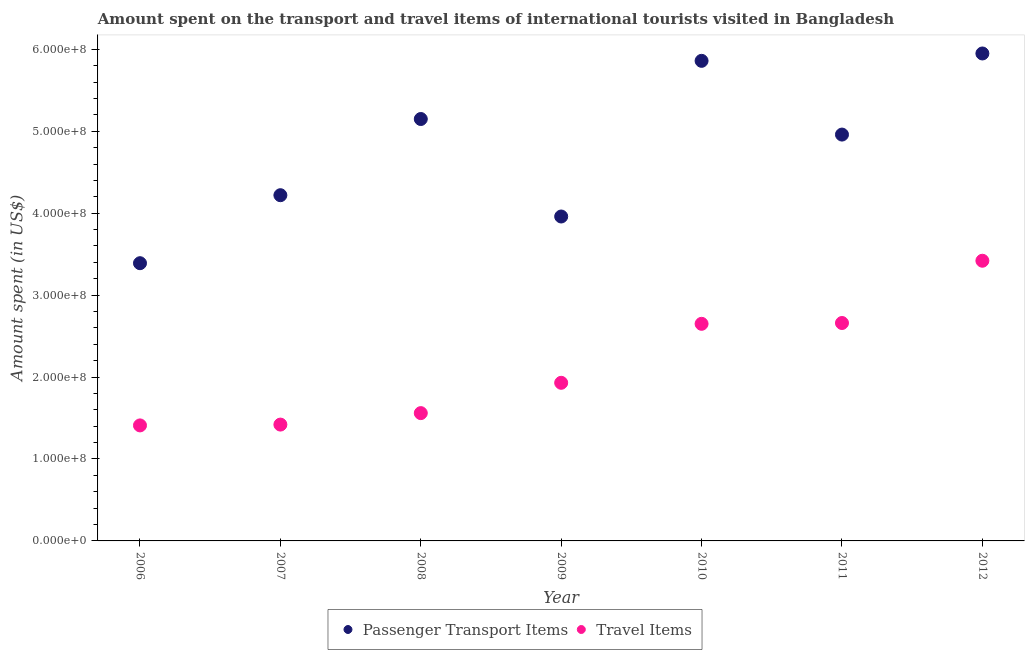What is the amount spent in travel items in 2012?
Offer a very short reply. 3.42e+08. Across all years, what is the maximum amount spent on passenger transport items?
Give a very brief answer. 5.95e+08. Across all years, what is the minimum amount spent in travel items?
Offer a terse response. 1.41e+08. In which year was the amount spent in travel items maximum?
Give a very brief answer. 2012. What is the total amount spent on passenger transport items in the graph?
Your response must be concise. 3.35e+09. What is the difference between the amount spent on passenger transport items in 2007 and that in 2012?
Give a very brief answer. -1.73e+08. What is the difference between the amount spent in travel items in 2010 and the amount spent on passenger transport items in 2006?
Make the answer very short. -7.40e+07. What is the average amount spent on passenger transport items per year?
Provide a succinct answer. 4.78e+08. In the year 2012, what is the difference between the amount spent in travel items and amount spent on passenger transport items?
Give a very brief answer. -2.53e+08. In how many years, is the amount spent in travel items greater than 80000000 US$?
Offer a very short reply. 7. What is the ratio of the amount spent on passenger transport items in 2010 to that in 2012?
Your response must be concise. 0.98. Is the difference between the amount spent on passenger transport items in 2007 and 2012 greater than the difference between the amount spent in travel items in 2007 and 2012?
Keep it short and to the point. Yes. What is the difference between the highest and the second highest amount spent on passenger transport items?
Offer a terse response. 9.00e+06. What is the difference between the highest and the lowest amount spent in travel items?
Keep it short and to the point. 2.01e+08. Is the sum of the amount spent on passenger transport items in 2009 and 2011 greater than the maximum amount spent in travel items across all years?
Make the answer very short. Yes. Does the amount spent in travel items monotonically increase over the years?
Ensure brevity in your answer.  Yes. Is the amount spent on passenger transport items strictly less than the amount spent in travel items over the years?
Your response must be concise. No. How many dotlines are there?
Ensure brevity in your answer.  2. What is the difference between two consecutive major ticks on the Y-axis?
Provide a short and direct response. 1.00e+08. Does the graph contain any zero values?
Give a very brief answer. No. Does the graph contain grids?
Offer a terse response. No. Where does the legend appear in the graph?
Provide a short and direct response. Bottom center. How are the legend labels stacked?
Give a very brief answer. Horizontal. What is the title of the graph?
Your answer should be very brief. Amount spent on the transport and travel items of international tourists visited in Bangladesh. Does "Short-term debt" appear as one of the legend labels in the graph?
Make the answer very short. No. What is the label or title of the Y-axis?
Ensure brevity in your answer.  Amount spent (in US$). What is the Amount spent (in US$) in Passenger Transport Items in 2006?
Ensure brevity in your answer.  3.39e+08. What is the Amount spent (in US$) of Travel Items in 2006?
Offer a terse response. 1.41e+08. What is the Amount spent (in US$) in Passenger Transport Items in 2007?
Make the answer very short. 4.22e+08. What is the Amount spent (in US$) in Travel Items in 2007?
Offer a terse response. 1.42e+08. What is the Amount spent (in US$) in Passenger Transport Items in 2008?
Provide a succinct answer. 5.15e+08. What is the Amount spent (in US$) of Travel Items in 2008?
Your response must be concise. 1.56e+08. What is the Amount spent (in US$) in Passenger Transport Items in 2009?
Make the answer very short. 3.96e+08. What is the Amount spent (in US$) in Travel Items in 2009?
Ensure brevity in your answer.  1.93e+08. What is the Amount spent (in US$) of Passenger Transport Items in 2010?
Keep it short and to the point. 5.86e+08. What is the Amount spent (in US$) in Travel Items in 2010?
Provide a short and direct response. 2.65e+08. What is the Amount spent (in US$) in Passenger Transport Items in 2011?
Your answer should be compact. 4.96e+08. What is the Amount spent (in US$) in Travel Items in 2011?
Keep it short and to the point. 2.66e+08. What is the Amount spent (in US$) in Passenger Transport Items in 2012?
Keep it short and to the point. 5.95e+08. What is the Amount spent (in US$) of Travel Items in 2012?
Provide a succinct answer. 3.42e+08. Across all years, what is the maximum Amount spent (in US$) in Passenger Transport Items?
Provide a succinct answer. 5.95e+08. Across all years, what is the maximum Amount spent (in US$) in Travel Items?
Offer a terse response. 3.42e+08. Across all years, what is the minimum Amount spent (in US$) of Passenger Transport Items?
Provide a short and direct response. 3.39e+08. Across all years, what is the minimum Amount spent (in US$) in Travel Items?
Offer a very short reply. 1.41e+08. What is the total Amount spent (in US$) of Passenger Transport Items in the graph?
Offer a terse response. 3.35e+09. What is the total Amount spent (in US$) in Travel Items in the graph?
Make the answer very short. 1.50e+09. What is the difference between the Amount spent (in US$) in Passenger Transport Items in 2006 and that in 2007?
Provide a short and direct response. -8.30e+07. What is the difference between the Amount spent (in US$) of Passenger Transport Items in 2006 and that in 2008?
Your response must be concise. -1.76e+08. What is the difference between the Amount spent (in US$) of Travel Items in 2006 and that in 2008?
Your response must be concise. -1.50e+07. What is the difference between the Amount spent (in US$) in Passenger Transport Items in 2006 and that in 2009?
Provide a succinct answer. -5.70e+07. What is the difference between the Amount spent (in US$) in Travel Items in 2006 and that in 2009?
Provide a short and direct response. -5.20e+07. What is the difference between the Amount spent (in US$) in Passenger Transport Items in 2006 and that in 2010?
Your answer should be very brief. -2.47e+08. What is the difference between the Amount spent (in US$) of Travel Items in 2006 and that in 2010?
Make the answer very short. -1.24e+08. What is the difference between the Amount spent (in US$) of Passenger Transport Items in 2006 and that in 2011?
Ensure brevity in your answer.  -1.57e+08. What is the difference between the Amount spent (in US$) in Travel Items in 2006 and that in 2011?
Your answer should be compact. -1.25e+08. What is the difference between the Amount spent (in US$) of Passenger Transport Items in 2006 and that in 2012?
Your answer should be compact. -2.56e+08. What is the difference between the Amount spent (in US$) in Travel Items in 2006 and that in 2012?
Your answer should be very brief. -2.01e+08. What is the difference between the Amount spent (in US$) in Passenger Transport Items in 2007 and that in 2008?
Your answer should be compact. -9.30e+07. What is the difference between the Amount spent (in US$) of Travel Items in 2007 and that in 2008?
Make the answer very short. -1.40e+07. What is the difference between the Amount spent (in US$) in Passenger Transport Items in 2007 and that in 2009?
Your answer should be very brief. 2.60e+07. What is the difference between the Amount spent (in US$) of Travel Items in 2007 and that in 2009?
Ensure brevity in your answer.  -5.10e+07. What is the difference between the Amount spent (in US$) of Passenger Transport Items in 2007 and that in 2010?
Your response must be concise. -1.64e+08. What is the difference between the Amount spent (in US$) of Travel Items in 2007 and that in 2010?
Provide a succinct answer. -1.23e+08. What is the difference between the Amount spent (in US$) in Passenger Transport Items in 2007 and that in 2011?
Give a very brief answer. -7.40e+07. What is the difference between the Amount spent (in US$) in Travel Items in 2007 and that in 2011?
Provide a succinct answer. -1.24e+08. What is the difference between the Amount spent (in US$) of Passenger Transport Items in 2007 and that in 2012?
Make the answer very short. -1.73e+08. What is the difference between the Amount spent (in US$) in Travel Items in 2007 and that in 2012?
Provide a short and direct response. -2.00e+08. What is the difference between the Amount spent (in US$) in Passenger Transport Items in 2008 and that in 2009?
Make the answer very short. 1.19e+08. What is the difference between the Amount spent (in US$) in Travel Items in 2008 and that in 2009?
Make the answer very short. -3.70e+07. What is the difference between the Amount spent (in US$) in Passenger Transport Items in 2008 and that in 2010?
Provide a short and direct response. -7.10e+07. What is the difference between the Amount spent (in US$) in Travel Items in 2008 and that in 2010?
Give a very brief answer. -1.09e+08. What is the difference between the Amount spent (in US$) of Passenger Transport Items in 2008 and that in 2011?
Provide a succinct answer. 1.90e+07. What is the difference between the Amount spent (in US$) in Travel Items in 2008 and that in 2011?
Offer a terse response. -1.10e+08. What is the difference between the Amount spent (in US$) of Passenger Transport Items in 2008 and that in 2012?
Your answer should be very brief. -8.00e+07. What is the difference between the Amount spent (in US$) of Travel Items in 2008 and that in 2012?
Provide a succinct answer. -1.86e+08. What is the difference between the Amount spent (in US$) of Passenger Transport Items in 2009 and that in 2010?
Your answer should be very brief. -1.90e+08. What is the difference between the Amount spent (in US$) of Travel Items in 2009 and that in 2010?
Your response must be concise. -7.20e+07. What is the difference between the Amount spent (in US$) of Passenger Transport Items in 2009 and that in 2011?
Provide a short and direct response. -1.00e+08. What is the difference between the Amount spent (in US$) in Travel Items in 2009 and that in 2011?
Your response must be concise. -7.30e+07. What is the difference between the Amount spent (in US$) in Passenger Transport Items in 2009 and that in 2012?
Offer a terse response. -1.99e+08. What is the difference between the Amount spent (in US$) of Travel Items in 2009 and that in 2012?
Your response must be concise. -1.49e+08. What is the difference between the Amount spent (in US$) of Passenger Transport Items in 2010 and that in 2011?
Offer a very short reply. 9.00e+07. What is the difference between the Amount spent (in US$) in Travel Items in 2010 and that in 2011?
Make the answer very short. -1.00e+06. What is the difference between the Amount spent (in US$) in Passenger Transport Items in 2010 and that in 2012?
Ensure brevity in your answer.  -9.00e+06. What is the difference between the Amount spent (in US$) of Travel Items in 2010 and that in 2012?
Provide a short and direct response. -7.70e+07. What is the difference between the Amount spent (in US$) of Passenger Transport Items in 2011 and that in 2012?
Keep it short and to the point. -9.90e+07. What is the difference between the Amount spent (in US$) of Travel Items in 2011 and that in 2012?
Keep it short and to the point. -7.60e+07. What is the difference between the Amount spent (in US$) in Passenger Transport Items in 2006 and the Amount spent (in US$) in Travel Items in 2007?
Keep it short and to the point. 1.97e+08. What is the difference between the Amount spent (in US$) of Passenger Transport Items in 2006 and the Amount spent (in US$) of Travel Items in 2008?
Your answer should be very brief. 1.83e+08. What is the difference between the Amount spent (in US$) of Passenger Transport Items in 2006 and the Amount spent (in US$) of Travel Items in 2009?
Your response must be concise. 1.46e+08. What is the difference between the Amount spent (in US$) in Passenger Transport Items in 2006 and the Amount spent (in US$) in Travel Items in 2010?
Provide a short and direct response. 7.40e+07. What is the difference between the Amount spent (in US$) of Passenger Transport Items in 2006 and the Amount spent (in US$) of Travel Items in 2011?
Your answer should be very brief. 7.30e+07. What is the difference between the Amount spent (in US$) of Passenger Transport Items in 2006 and the Amount spent (in US$) of Travel Items in 2012?
Offer a very short reply. -3.00e+06. What is the difference between the Amount spent (in US$) of Passenger Transport Items in 2007 and the Amount spent (in US$) of Travel Items in 2008?
Provide a short and direct response. 2.66e+08. What is the difference between the Amount spent (in US$) in Passenger Transport Items in 2007 and the Amount spent (in US$) in Travel Items in 2009?
Provide a succinct answer. 2.29e+08. What is the difference between the Amount spent (in US$) of Passenger Transport Items in 2007 and the Amount spent (in US$) of Travel Items in 2010?
Offer a terse response. 1.57e+08. What is the difference between the Amount spent (in US$) of Passenger Transport Items in 2007 and the Amount spent (in US$) of Travel Items in 2011?
Your answer should be compact. 1.56e+08. What is the difference between the Amount spent (in US$) in Passenger Transport Items in 2007 and the Amount spent (in US$) in Travel Items in 2012?
Make the answer very short. 8.00e+07. What is the difference between the Amount spent (in US$) of Passenger Transport Items in 2008 and the Amount spent (in US$) of Travel Items in 2009?
Provide a succinct answer. 3.22e+08. What is the difference between the Amount spent (in US$) of Passenger Transport Items in 2008 and the Amount spent (in US$) of Travel Items in 2010?
Provide a short and direct response. 2.50e+08. What is the difference between the Amount spent (in US$) of Passenger Transport Items in 2008 and the Amount spent (in US$) of Travel Items in 2011?
Your response must be concise. 2.49e+08. What is the difference between the Amount spent (in US$) of Passenger Transport Items in 2008 and the Amount spent (in US$) of Travel Items in 2012?
Provide a short and direct response. 1.73e+08. What is the difference between the Amount spent (in US$) in Passenger Transport Items in 2009 and the Amount spent (in US$) in Travel Items in 2010?
Offer a very short reply. 1.31e+08. What is the difference between the Amount spent (in US$) in Passenger Transport Items in 2009 and the Amount spent (in US$) in Travel Items in 2011?
Keep it short and to the point. 1.30e+08. What is the difference between the Amount spent (in US$) in Passenger Transport Items in 2009 and the Amount spent (in US$) in Travel Items in 2012?
Keep it short and to the point. 5.40e+07. What is the difference between the Amount spent (in US$) of Passenger Transport Items in 2010 and the Amount spent (in US$) of Travel Items in 2011?
Provide a succinct answer. 3.20e+08. What is the difference between the Amount spent (in US$) in Passenger Transport Items in 2010 and the Amount spent (in US$) in Travel Items in 2012?
Give a very brief answer. 2.44e+08. What is the difference between the Amount spent (in US$) of Passenger Transport Items in 2011 and the Amount spent (in US$) of Travel Items in 2012?
Provide a short and direct response. 1.54e+08. What is the average Amount spent (in US$) in Passenger Transport Items per year?
Give a very brief answer. 4.78e+08. What is the average Amount spent (in US$) in Travel Items per year?
Keep it short and to the point. 2.15e+08. In the year 2006, what is the difference between the Amount spent (in US$) of Passenger Transport Items and Amount spent (in US$) of Travel Items?
Your answer should be very brief. 1.98e+08. In the year 2007, what is the difference between the Amount spent (in US$) in Passenger Transport Items and Amount spent (in US$) in Travel Items?
Provide a succinct answer. 2.80e+08. In the year 2008, what is the difference between the Amount spent (in US$) of Passenger Transport Items and Amount spent (in US$) of Travel Items?
Offer a very short reply. 3.59e+08. In the year 2009, what is the difference between the Amount spent (in US$) of Passenger Transport Items and Amount spent (in US$) of Travel Items?
Provide a short and direct response. 2.03e+08. In the year 2010, what is the difference between the Amount spent (in US$) in Passenger Transport Items and Amount spent (in US$) in Travel Items?
Keep it short and to the point. 3.21e+08. In the year 2011, what is the difference between the Amount spent (in US$) in Passenger Transport Items and Amount spent (in US$) in Travel Items?
Offer a terse response. 2.30e+08. In the year 2012, what is the difference between the Amount spent (in US$) in Passenger Transport Items and Amount spent (in US$) in Travel Items?
Keep it short and to the point. 2.53e+08. What is the ratio of the Amount spent (in US$) in Passenger Transport Items in 2006 to that in 2007?
Give a very brief answer. 0.8. What is the ratio of the Amount spent (in US$) in Passenger Transport Items in 2006 to that in 2008?
Ensure brevity in your answer.  0.66. What is the ratio of the Amount spent (in US$) of Travel Items in 2006 to that in 2008?
Your answer should be compact. 0.9. What is the ratio of the Amount spent (in US$) in Passenger Transport Items in 2006 to that in 2009?
Keep it short and to the point. 0.86. What is the ratio of the Amount spent (in US$) of Travel Items in 2006 to that in 2009?
Offer a very short reply. 0.73. What is the ratio of the Amount spent (in US$) of Passenger Transport Items in 2006 to that in 2010?
Your response must be concise. 0.58. What is the ratio of the Amount spent (in US$) of Travel Items in 2006 to that in 2010?
Offer a terse response. 0.53. What is the ratio of the Amount spent (in US$) in Passenger Transport Items in 2006 to that in 2011?
Your answer should be compact. 0.68. What is the ratio of the Amount spent (in US$) in Travel Items in 2006 to that in 2011?
Ensure brevity in your answer.  0.53. What is the ratio of the Amount spent (in US$) of Passenger Transport Items in 2006 to that in 2012?
Provide a succinct answer. 0.57. What is the ratio of the Amount spent (in US$) of Travel Items in 2006 to that in 2012?
Your response must be concise. 0.41. What is the ratio of the Amount spent (in US$) in Passenger Transport Items in 2007 to that in 2008?
Make the answer very short. 0.82. What is the ratio of the Amount spent (in US$) of Travel Items in 2007 to that in 2008?
Provide a short and direct response. 0.91. What is the ratio of the Amount spent (in US$) in Passenger Transport Items in 2007 to that in 2009?
Ensure brevity in your answer.  1.07. What is the ratio of the Amount spent (in US$) in Travel Items in 2007 to that in 2009?
Provide a succinct answer. 0.74. What is the ratio of the Amount spent (in US$) of Passenger Transport Items in 2007 to that in 2010?
Offer a very short reply. 0.72. What is the ratio of the Amount spent (in US$) of Travel Items in 2007 to that in 2010?
Provide a short and direct response. 0.54. What is the ratio of the Amount spent (in US$) of Passenger Transport Items in 2007 to that in 2011?
Make the answer very short. 0.85. What is the ratio of the Amount spent (in US$) in Travel Items in 2007 to that in 2011?
Your response must be concise. 0.53. What is the ratio of the Amount spent (in US$) in Passenger Transport Items in 2007 to that in 2012?
Provide a succinct answer. 0.71. What is the ratio of the Amount spent (in US$) of Travel Items in 2007 to that in 2012?
Give a very brief answer. 0.42. What is the ratio of the Amount spent (in US$) in Passenger Transport Items in 2008 to that in 2009?
Your answer should be compact. 1.3. What is the ratio of the Amount spent (in US$) in Travel Items in 2008 to that in 2009?
Provide a short and direct response. 0.81. What is the ratio of the Amount spent (in US$) of Passenger Transport Items in 2008 to that in 2010?
Offer a very short reply. 0.88. What is the ratio of the Amount spent (in US$) in Travel Items in 2008 to that in 2010?
Offer a very short reply. 0.59. What is the ratio of the Amount spent (in US$) in Passenger Transport Items in 2008 to that in 2011?
Keep it short and to the point. 1.04. What is the ratio of the Amount spent (in US$) in Travel Items in 2008 to that in 2011?
Your answer should be compact. 0.59. What is the ratio of the Amount spent (in US$) in Passenger Transport Items in 2008 to that in 2012?
Provide a succinct answer. 0.87. What is the ratio of the Amount spent (in US$) of Travel Items in 2008 to that in 2012?
Your response must be concise. 0.46. What is the ratio of the Amount spent (in US$) in Passenger Transport Items in 2009 to that in 2010?
Your answer should be very brief. 0.68. What is the ratio of the Amount spent (in US$) of Travel Items in 2009 to that in 2010?
Make the answer very short. 0.73. What is the ratio of the Amount spent (in US$) of Passenger Transport Items in 2009 to that in 2011?
Your response must be concise. 0.8. What is the ratio of the Amount spent (in US$) in Travel Items in 2009 to that in 2011?
Provide a short and direct response. 0.73. What is the ratio of the Amount spent (in US$) in Passenger Transport Items in 2009 to that in 2012?
Provide a short and direct response. 0.67. What is the ratio of the Amount spent (in US$) in Travel Items in 2009 to that in 2012?
Provide a succinct answer. 0.56. What is the ratio of the Amount spent (in US$) of Passenger Transport Items in 2010 to that in 2011?
Your answer should be compact. 1.18. What is the ratio of the Amount spent (in US$) in Passenger Transport Items in 2010 to that in 2012?
Your answer should be compact. 0.98. What is the ratio of the Amount spent (in US$) of Travel Items in 2010 to that in 2012?
Provide a succinct answer. 0.77. What is the ratio of the Amount spent (in US$) in Passenger Transport Items in 2011 to that in 2012?
Provide a short and direct response. 0.83. What is the difference between the highest and the second highest Amount spent (in US$) in Passenger Transport Items?
Offer a very short reply. 9.00e+06. What is the difference between the highest and the second highest Amount spent (in US$) in Travel Items?
Your answer should be very brief. 7.60e+07. What is the difference between the highest and the lowest Amount spent (in US$) of Passenger Transport Items?
Your answer should be compact. 2.56e+08. What is the difference between the highest and the lowest Amount spent (in US$) in Travel Items?
Provide a succinct answer. 2.01e+08. 